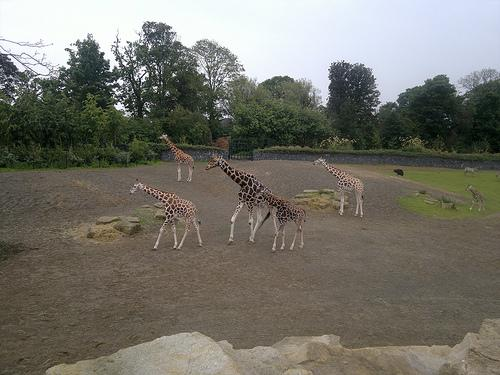What kind of sentiment or atmosphere does the image evoke? The image gives off a peaceful and natural atmosphere, with the animals and surrounding landscape interacting harmoniously. Describe some of the vegetation or foliage features found in the image. There are green trees in the distance, thick grass in one area, and branches without leaves on some trees. Describe any boundaries or barriers present in the image. There is a black gate in a stone wall, a fence between two rock barriers, and a small stone wall in the image. What are the unique features of a giraffe that can be seen in this image? The giraffes have long necks, white legs, and brown and tan spots in the image. What interactions can be seen between different objects or animals within the image? Adult giraffes are walking next to juvenile giraffes, while some giraffes are walking on dirt ground toward the left. Can you describe the colors and characteristics of the sky in the image? The sky is open and blue, and is described as very cloudy in the image. What are the animals found in the image and in what type of area are they located? Giraffes and a zebra are present in the image, located in a large dirt field with patches of grass and rocks. Identify the types of giraffes in the image and their specific characteristics. There are adult and young giraffes with yellow and brown spots, some of them walking across the dirt field. What is the environment like outside of the animals' pen? There is a tree line, some tall trees, rocks, and a large rock formation outside the pen. How many types of surfaces are there in the image and what are they like? There are three types of surfaces: grey rock surface, patch of brown dirt on the ground, and field full of dirt. Can you see a large body of water in the middle of the field? There is no body of water in the image; it consists of dirt fields and grassy areas. Where's the rainbow in the open blue sky? There is no rainbow in the image; the sky is mentioned as being cloudy, making a rainbow unlikely. Can you find the lion walking on the dirt ground towards the left? There is no lion in the image; a giraffe is actually walking on the dirt ground towards the left. Which building is behind the black gate? There is no building in the image; only a dirt field, grass, trees, and animals are present. Can you spot the red car parked near the stone wall? There is no red car or any vehicle in the image; the setting is a natural environment with giraffes. Where is the pink flower in the foreground? There is no pink flower in the image; the focus is on giraffes, dirt field, grass, trees, and rocks. 